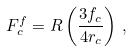Convert formula to latex. <formula><loc_0><loc_0><loc_500><loc_500>F _ { c } ^ { f } = R \left ( \frac { 3 f _ { c } } { 4 r _ { c } } \right ) \, ,</formula> 